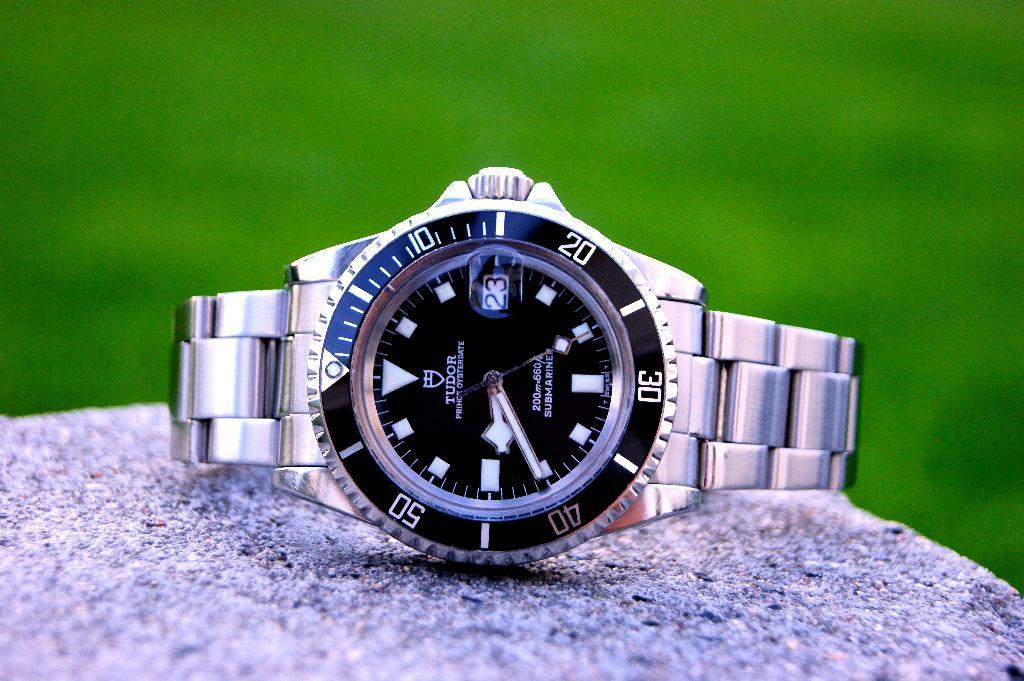<image>
Summarize the visual content of the image. A wristwatch bears the brand name Tudor on it. 